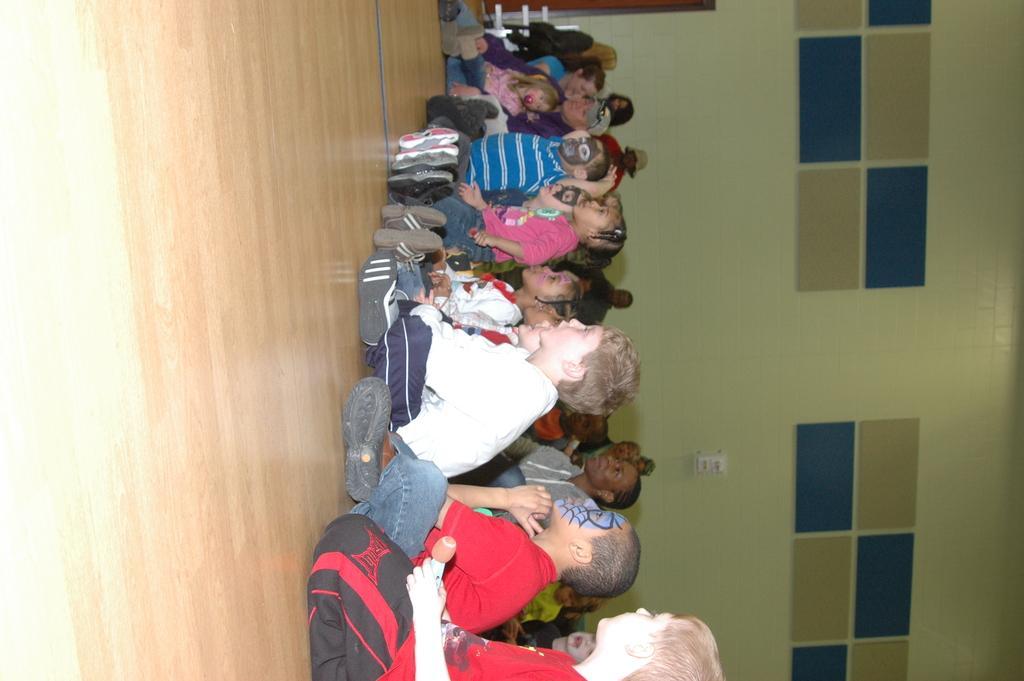Describe this image in one or two sentences. In this image we can see a group of children sitting on the wooden floor. Here we can see a few women. Here we can see a few children with costumes on their faces. 